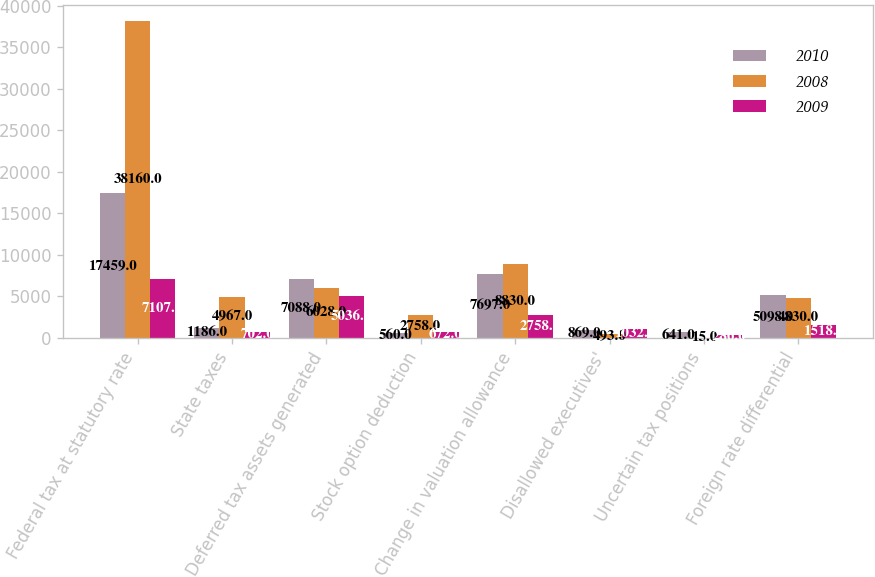Convert chart. <chart><loc_0><loc_0><loc_500><loc_500><stacked_bar_chart><ecel><fcel>Federal tax at statutory rate<fcel>State taxes<fcel>Deferred tax assets generated<fcel>Stock option deduction<fcel>Change in valuation allowance<fcel>Disallowed executives'<fcel>Uncertain tax positions<fcel>Foreign rate differential<nl><fcel>2010<fcel>17459<fcel>1186<fcel>7088<fcel>560<fcel>7697<fcel>869<fcel>641<fcel>5098<nl><fcel>2008<fcel>38160<fcel>4967<fcel>6028<fcel>2758<fcel>8830<fcel>493<fcel>15<fcel>4830<nl><fcel>2009<fcel>7107<fcel>702<fcel>5036<fcel>672<fcel>2758<fcel>1032<fcel>286<fcel>1518<nl></chart> 